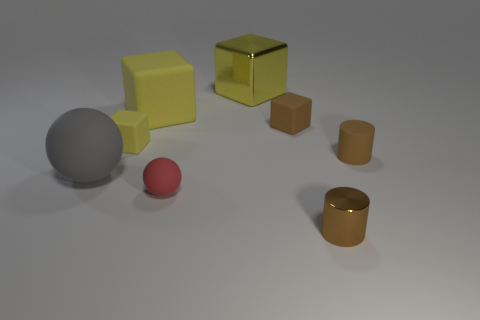Subtract all cyan cylinders. How many yellow cubes are left? 3 Add 1 tiny matte blocks. How many objects exist? 9 Subtract all cylinders. How many objects are left? 6 Subtract all large matte blocks. Subtract all small brown things. How many objects are left? 4 Add 5 large yellow blocks. How many large yellow blocks are left? 7 Add 5 big brown blocks. How many big brown blocks exist? 5 Subtract 0 purple spheres. How many objects are left? 8 